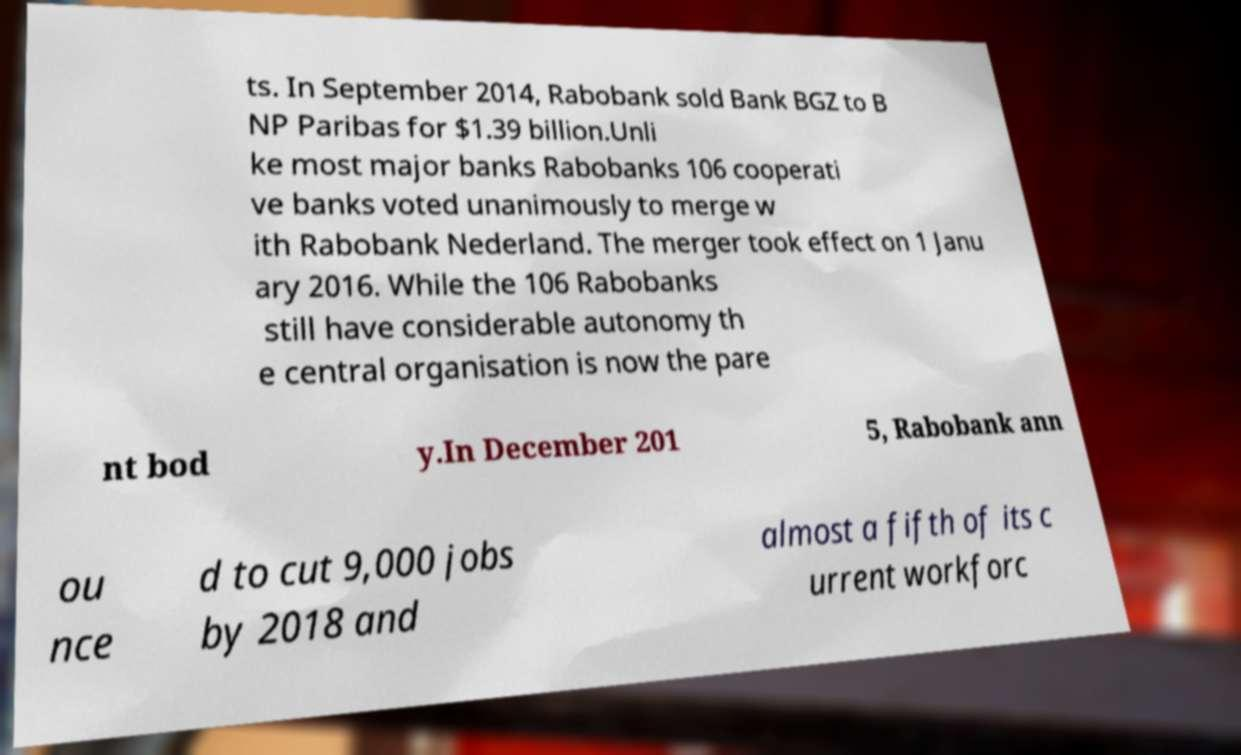Can you accurately transcribe the text from the provided image for me? ts. In September 2014, Rabobank sold Bank BGZ to B NP Paribas for $1.39 billion.Unli ke most major banks Rabobanks 106 cooperati ve banks voted unanimously to merge w ith Rabobank Nederland. The merger took effect on 1 Janu ary 2016. While the 106 Rabobanks still have considerable autonomy th e central organisation is now the pare nt bod y.In December 201 5, Rabobank ann ou nce d to cut 9,000 jobs by 2018 and almost a fifth of its c urrent workforc 